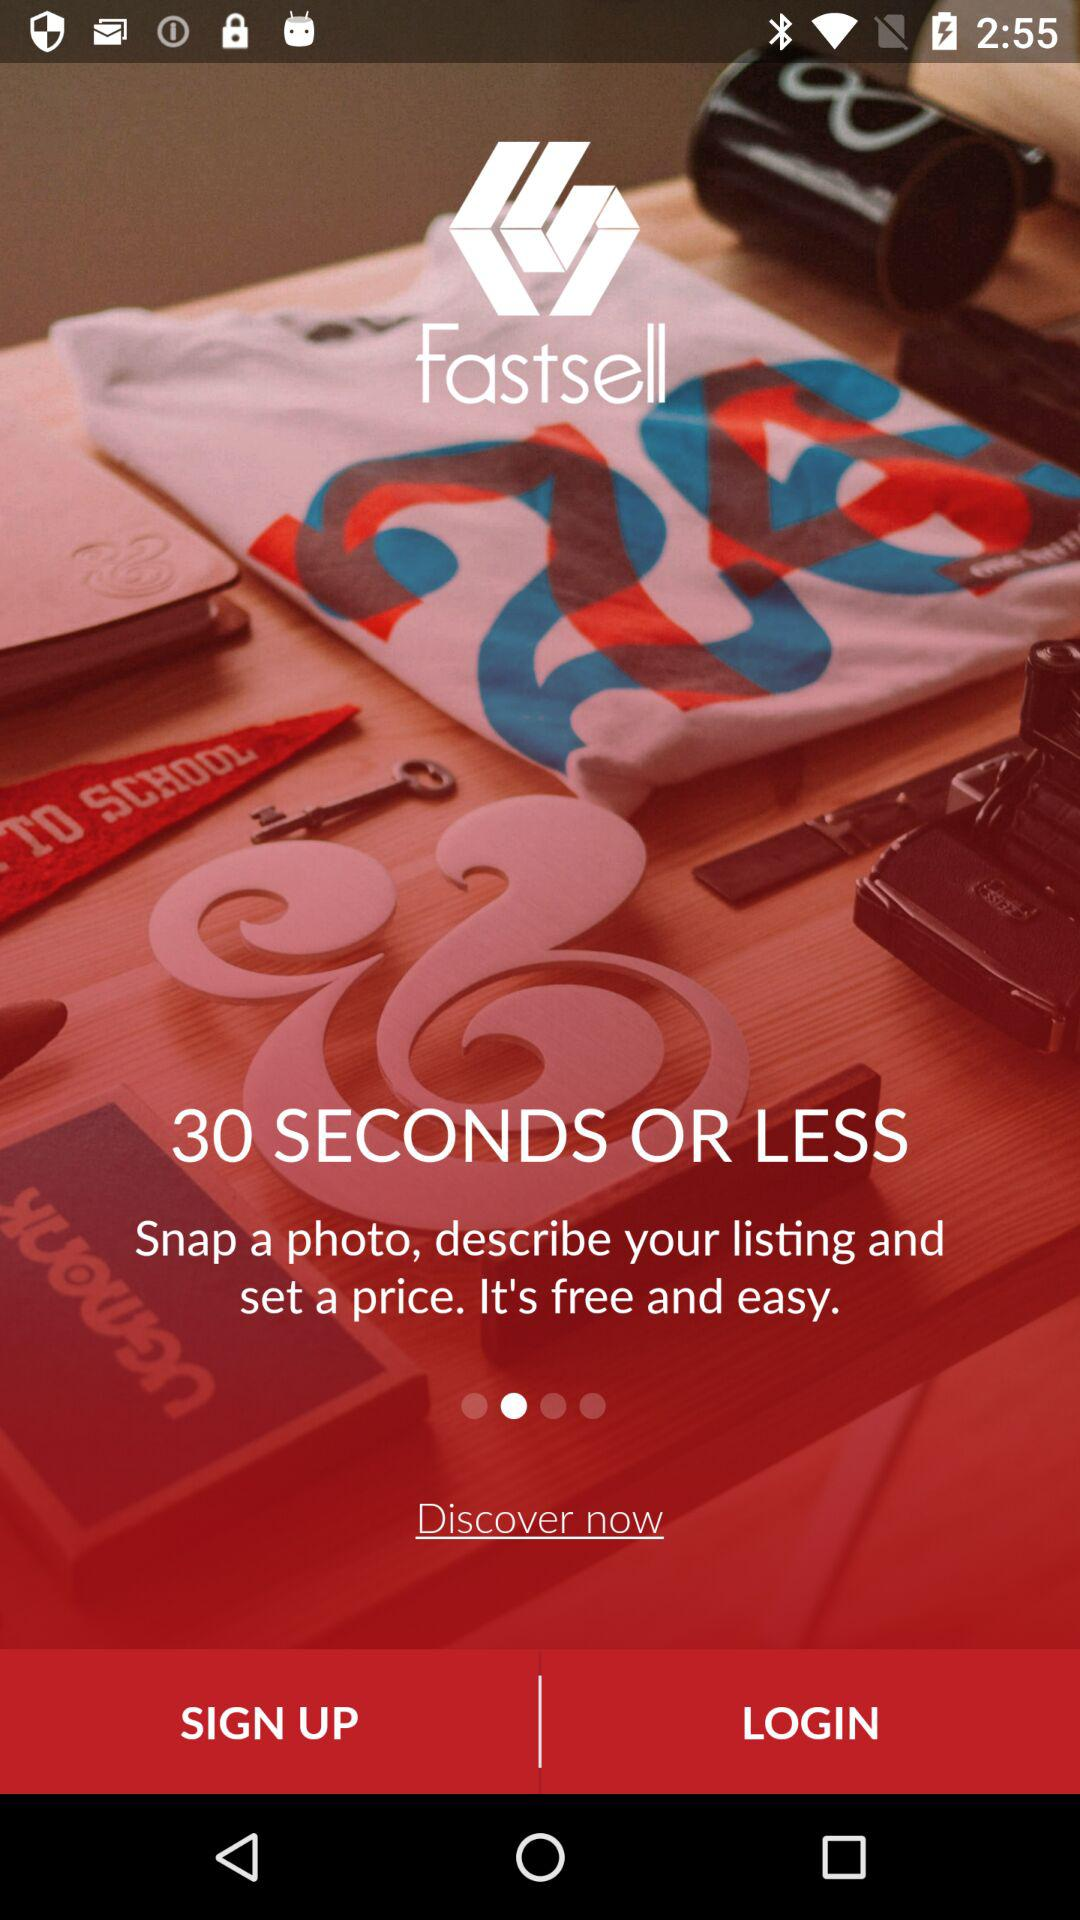What is the application name? The application name is "Fastsell". 